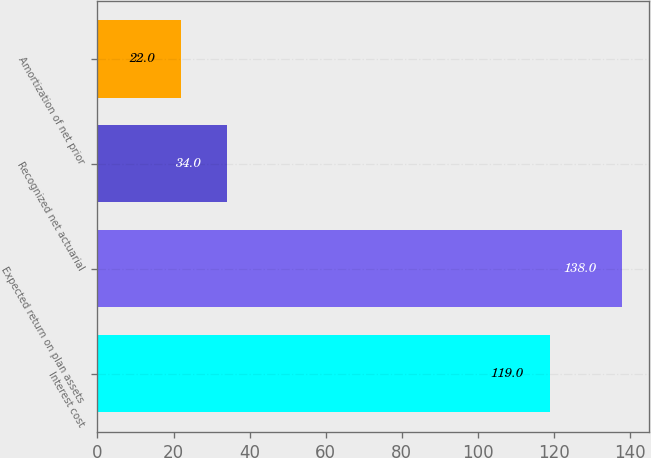Convert chart to OTSL. <chart><loc_0><loc_0><loc_500><loc_500><bar_chart><fcel>Interest cost<fcel>Expected return on plan assets<fcel>Recognized net actuarial<fcel>Amortization of net prior<nl><fcel>119<fcel>138<fcel>34<fcel>22<nl></chart> 